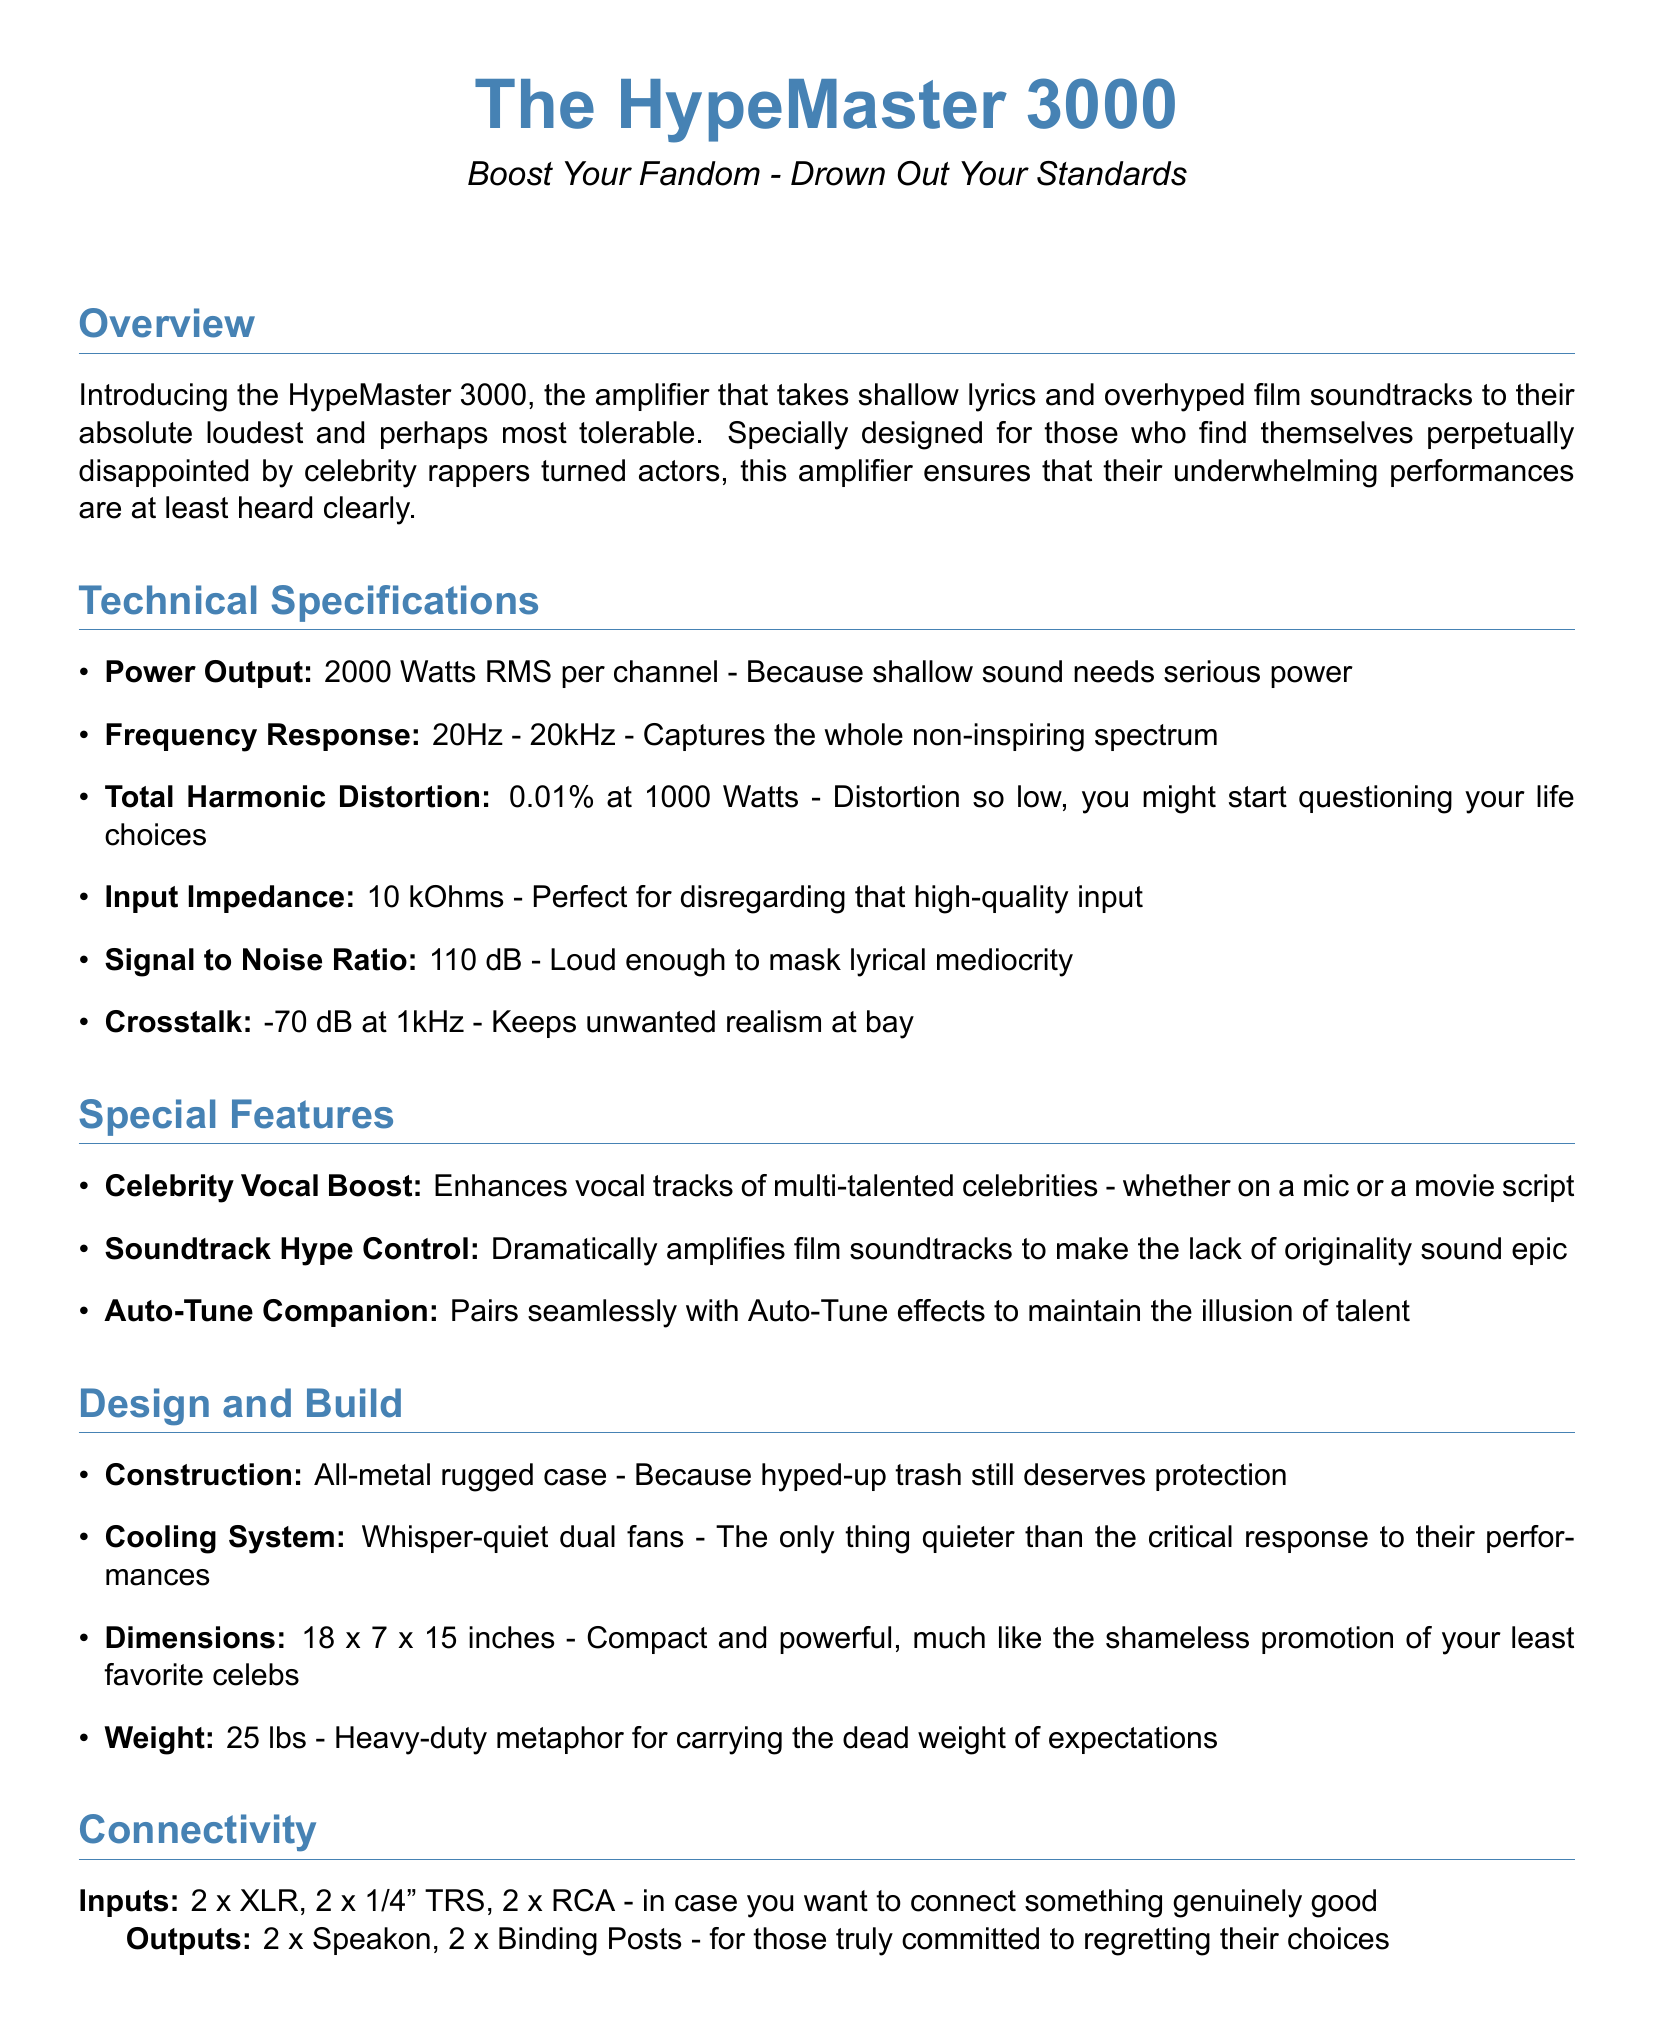what is the power output? The power output is specified in the technical specifications of the document, which states it is 2000 Watts RMS per channel.
Answer: 2000 Watts RMS per channel what is the total harmonic distortion? The total harmonic distortion is found in the technical specifications and is listed as 0.01% at 1000 Watts.
Answer: 0.01% what is the size of the amplifier? The dimensions are provided in the design and build section, which states it measures 18 x 7 x 15 inches.
Answer: 18 x 7 x 15 inches how heavy is the HypeMaster 3000? The weight of the amplifier is mentioned in the design and build section as 25 lbs.
Answer: 25 lbs what type of warranty does it come with? The user experience section discusses the warranty, which is stated to be for 2 years.
Answer: 2-year warranty what does the auto-tune companion do? The special features section describes the auto-tune companion as pairing seamlessly with Auto-Tune effects.
Answer: Pairs seamlessly with Auto-Tune effects how many XLR inputs does it have? The connectivity section specifies that there are 2 x XLR inputs.
Answer: 2 x XLR what is the MSRP of the HypeMaster 3000? The MSRP is mentioned at the end of the document, which is $499.
Answer: $499 what is the signal to noise ratio? The signal to noise ratio is found within the technical specifications and is stated as 110 dB.
Answer: 110 dB 